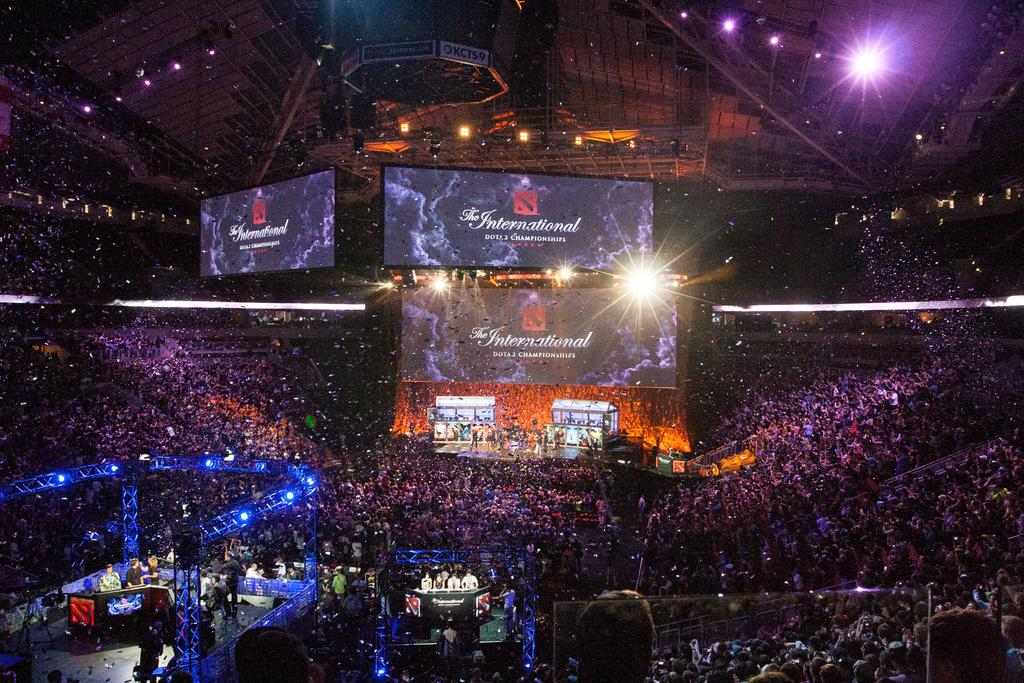What type of location is depicted in the image? The image appears to be of an indoor stadium. What can be seen on the screens in the image? There are screens displaying text in the image. What is the source of illumination in the image? There are lights on the ceiling in the image. What are the people in the image doing? There are people performing on a dais in the image. What type of field is visible in the image? There is no field visible in the image; it is an indoor stadium with a performance taking place on a dais. What is the heart rate of the person performing on the dais in the image? There is no information about the heart rate of the person performing in the image. 